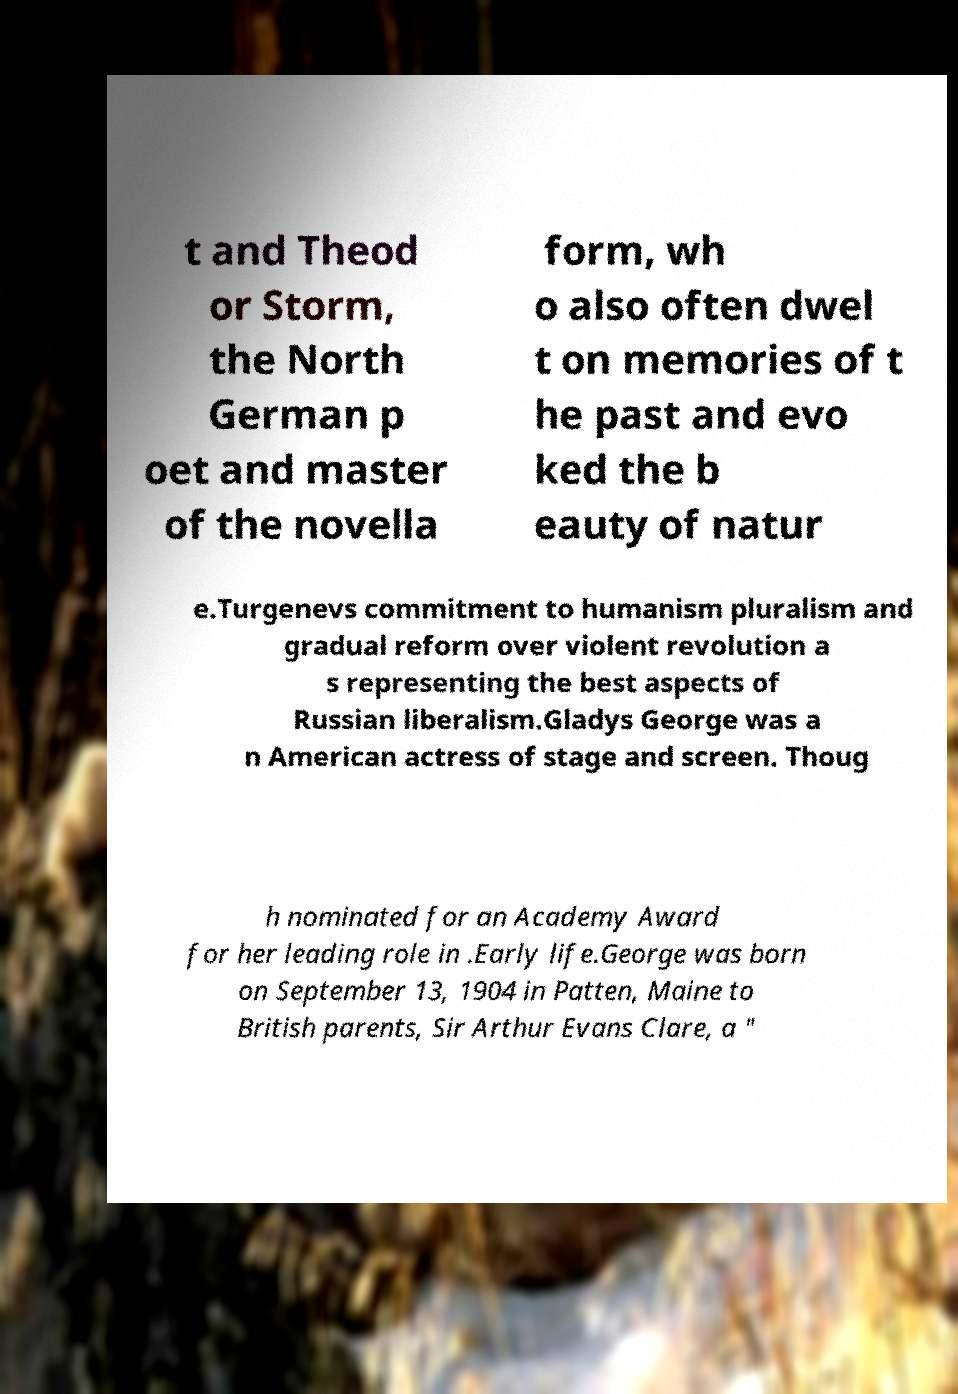Can you accurately transcribe the text from the provided image for me? t and Theod or Storm, the North German p oet and master of the novella form, wh o also often dwel t on memories of t he past and evo ked the b eauty of natur e.Turgenevs commitment to humanism pluralism and gradual reform over violent revolution a s representing the best aspects of Russian liberalism.Gladys George was a n American actress of stage and screen. Thoug h nominated for an Academy Award for her leading role in .Early life.George was born on September 13, 1904 in Patten, Maine to British parents, Sir Arthur Evans Clare, a " 